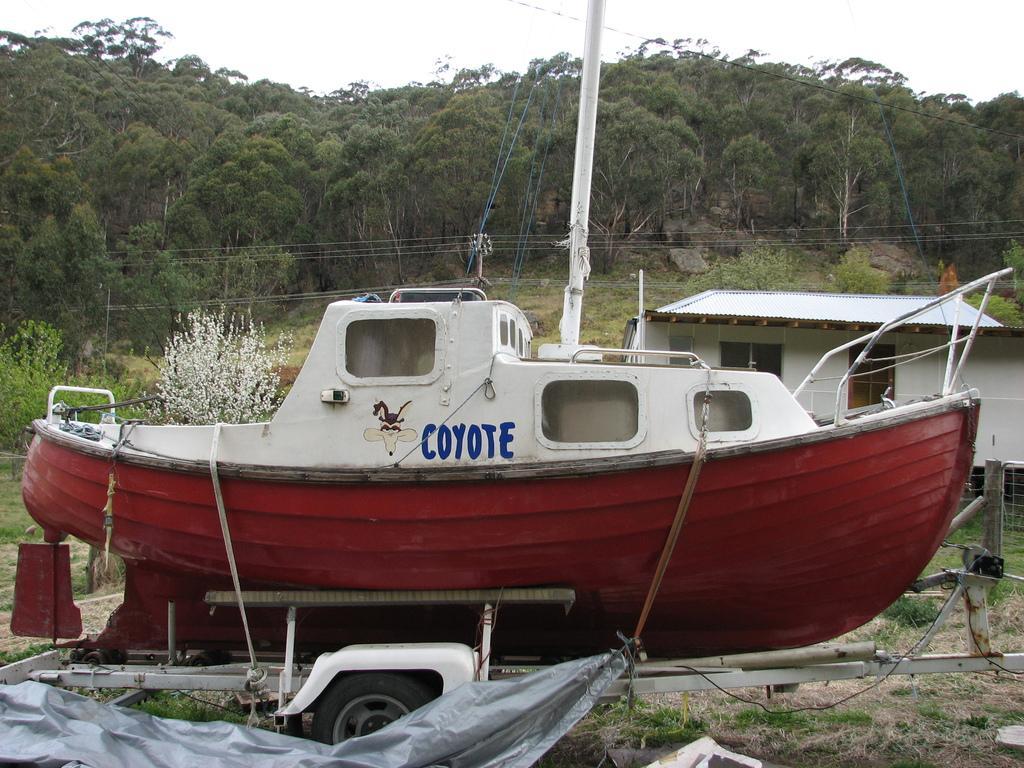Please provide a concise description of this image. This image is taken outdoors. At the top of the image there is the sky. At the bottom of the image there is a ground with grass on it. There is a sheet on the ground. In the background there are many trees and plants with leaves, stems and branches. There are few rocks. There is a pole with wires. There is a house. In the middle of the image there is a boat on the ground. 